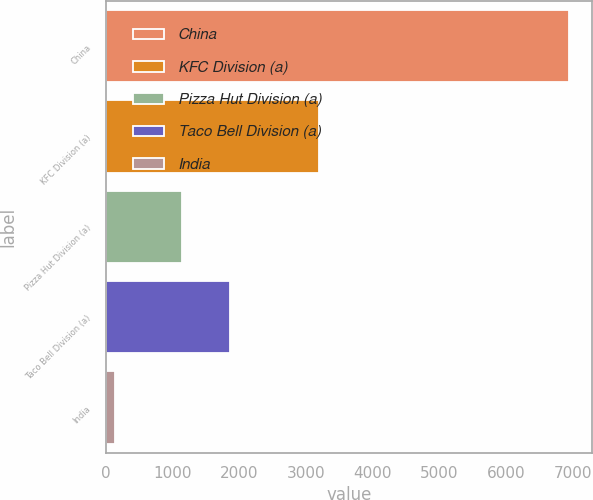<chart> <loc_0><loc_0><loc_500><loc_500><bar_chart><fcel>China<fcel>KFC Division (a)<fcel>Pizza Hut Division (a)<fcel>Taco Bell Division (a)<fcel>India<nl><fcel>6934<fcel>3193<fcel>1148<fcel>1863<fcel>141<nl></chart> 